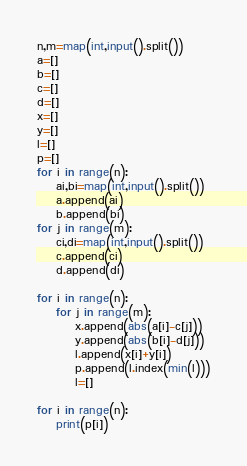Convert code to text. <code><loc_0><loc_0><loc_500><loc_500><_Python_>n,m=map(int,input().split())
a=[]
b=[]
c=[]
d=[]
x=[]
y=[]
l=[]
p=[]
for i in range(n):
    ai,bi=map(int,input().split())
    a.append(ai)
    b.append(bi)
for j in range(m):
    ci,di=map(int,input().split())
    c.append(ci)
    d.append(di)
    
for i in range(n):
    for j in range(m):
        x.append(abs(a[i]-c[j]))
        y.append(abs(b[i]-d[j]))
        l.append(x[i]+y[i])
        p.append(l.index(min(l)))
        l=[]
        
for i in range(n):
    print(p[i])</code> 